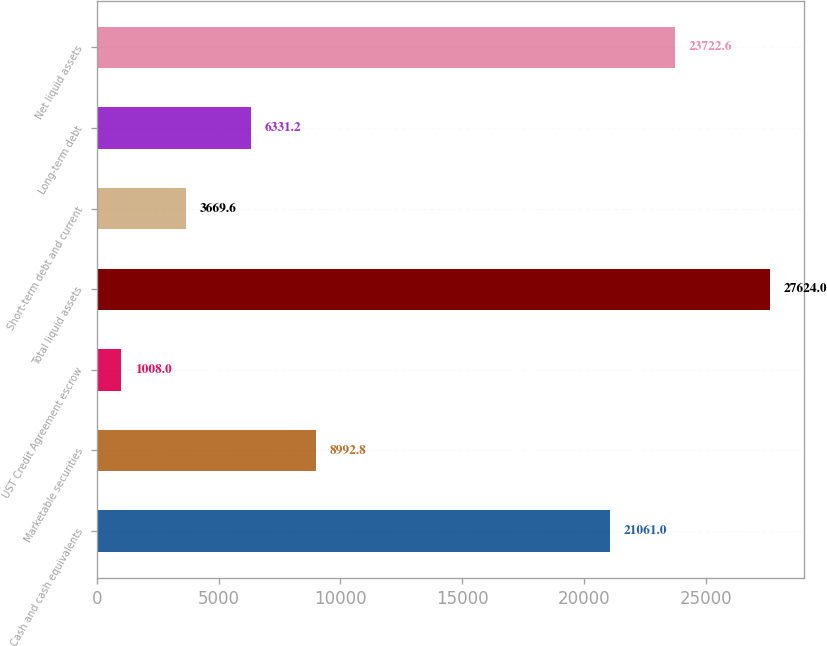<chart> <loc_0><loc_0><loc_500><loc_500><bar_chart><fcel>Cash and cash equivalents<fcel>Marketable securities<fcel>UST Credit Agreement escrow<fcel>Total liquid assets<fcel>Short-term debt and current<fcel>Long-term debt<fcel>Net liquid assets<nl><fcel>21061<fcel>8992.8<fcel>1008<fcel>27624<fcel>3669.6<fcel>6331.2<fcel>23722.6<nl></chart> 